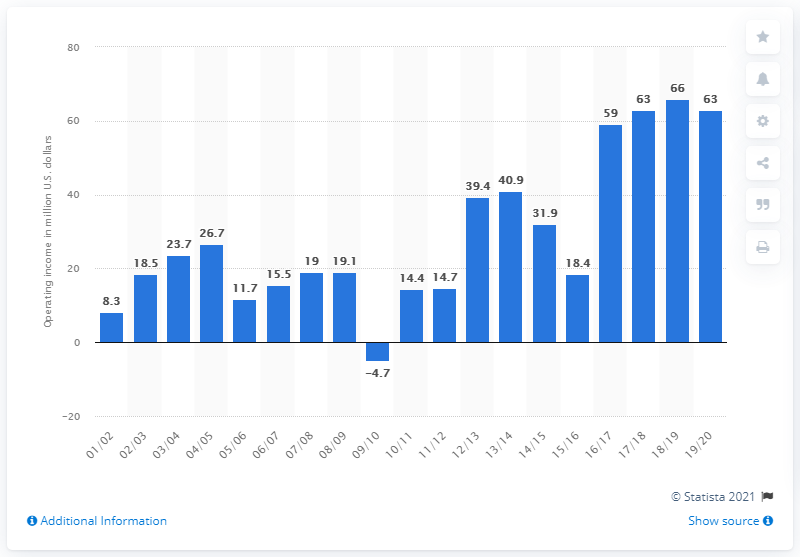Specify some key components in this picture. The operating income of the San Antonio Spurs in the 2019/20 season was approximately 63. 